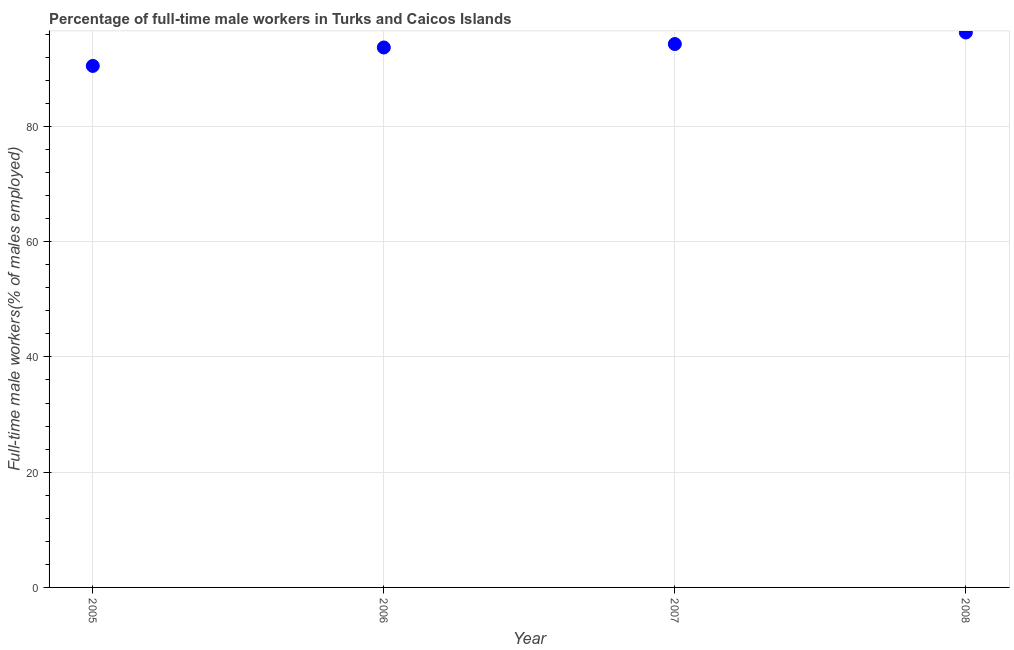What is the percentage of full-time male workers in 2008?
Your answer should be very brief. 96.3. Across all years, what is the maximum percentage of full-time male workers?
Your answer should be very brief. 96.3. Across all years, what is the minimum percentage of full-time male workers?
Offer a terse response. 90.5. In which year was the percentage of full-time male workers maximum?
Give a very brief answer. 2008. In which year was the percentage of full-time male workers minimum?
Provide a succinct answer. 2005. What is the sum of the percentage of full-time male workers?
Offer a very short reply. 374.8. What is the difference between the percentage of full-time male workers in 2005 and 2008?
Keep it short and to the point. -5.8. What is the average percentage of full-time male workers per year?
Offer a terse response. 93.7. What is the median percentage of full-time male workers?
Your answer should be compact. 94. What is the ratio of the percentage of full-time male workers in 2007 to that in 2008?
Offer a terse response. 0.98. Is the percentage of full-time male workers in 2005 less than that in 2008?
Your answer should be compact. Yes. Is the difference between the percentage of full-time male workers in 2005 and 2008 greater than the difference between any two years?
Ensure brevity in your answer.  Yes. What is the difference between the highest and the second highest percentage of full-time male workers?
Make the answer very short. 2. What is the difference between the highest and the lowest percentage of full-time male workers?
Offer a terse response. 5.8. How many dotlines are there?
Ensure brevity in your answer.  1. Are the values on the major ticks of Y-axis written in scientific E-notation?
Your response must be concise. No. Does the graph contain grids?
Give a very brief answer. Yes. What is the title of the graph?
Give a very brief answer. Percentage of full-time male workers in Turks and Caicos Islands. What is the label or title of the X-axis?
Your response must be concise. Year. What is the label or title of the Y-axis?
Your answer should be compact. Full-time male workers(% of males employed). What is the Full-time male workers(% of males employed) in 2005?
Provide a short and direct response. 90.5. What is the Full-time male workers(% of males employed) in 2006?
Give a very brief answer. 93.7. What is the Full-time male workers(% of males employed) in 2007?
Offer a terse response. 94.3. What is the Full-time male workers(% of males employed) in 2008?
Your answer should be compact. 96.3. What is the difference between the Full-time male workers(% of males employed) in 2005 and 2008?
Ensure brevity in your answer.  -5.8. What is the difference between the Full-time male workers(% of males employed) in 2006 and 2007?
Give a very brief answer. -0.6. What is the difference between the Full-time male workers(% of males employed) in 2006 and 2008?
Provide a short and direct response. -2.6. What is the difference between the Full-time male workers(% of males employed) in 2007 and 2008?
Give a very brief answer. -2. What is the ratio of the Full-time male workers(% of males employed) in 2005 to that in 2006?
Provide a succinct answer. 0.97. What is the ratio of the Full-time male workers(% of males employed) in 2006 to that in 2007?
Keep it short and to the point. 0.99. 